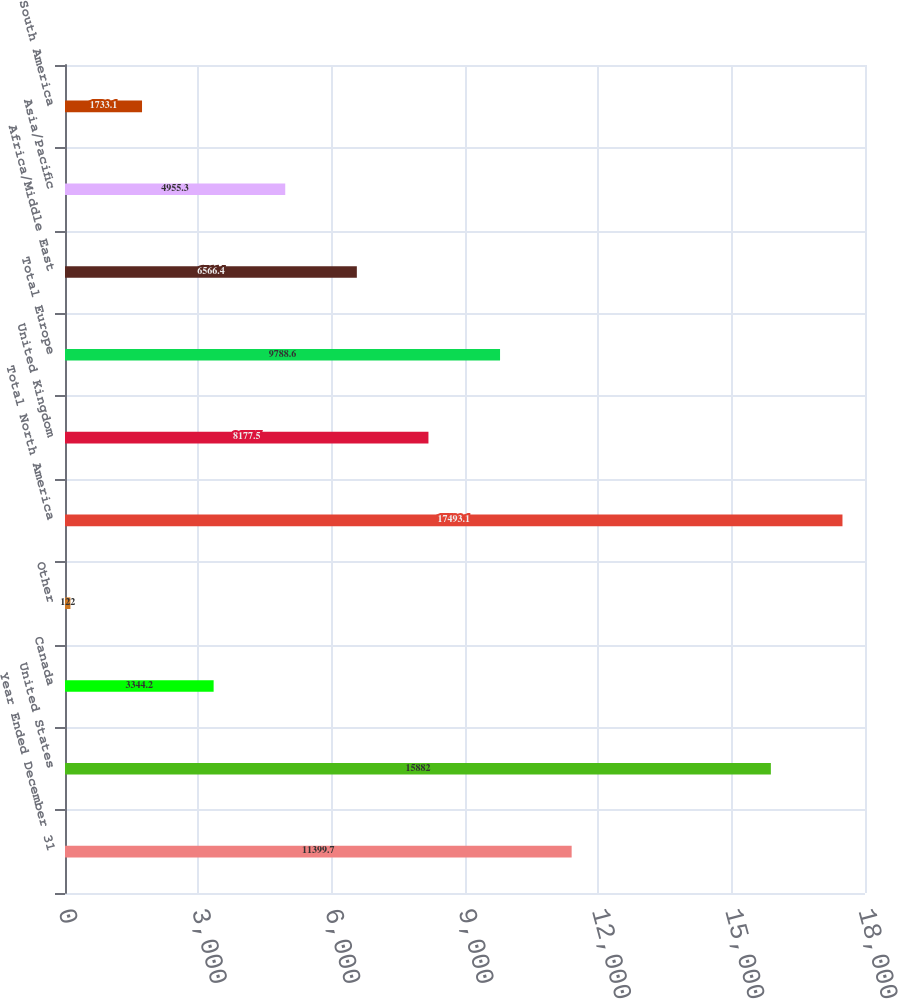Convert chart. <chart><loc_0><loc_0><loc_500><loc_500><bar_chart><fcel>Year Ended December 31<fcel>United States<fcel>Canada<fcel>Other<fcel>Total North America<fcel>United Kingdom<fcel>Total Europe<fcel>Africa/Middle East<fcel>Asia/Pacific<fcel>South America<nl><fcel>11399.7<fcel>15882<fcel>3344.2<fcel>122<fcel>17493.1<fcel>8177.5<fcel>9788.6<fcel>6566.4<fcel>4955.3<fcel>1733.1<nl></chart> 